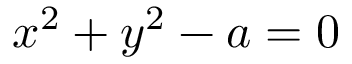Convert formula to latex. <formula><loc_0><loc_0><loc_500><loc_500>x ^ { 2 } + y ^ { 2 } - a = 0</formula> 